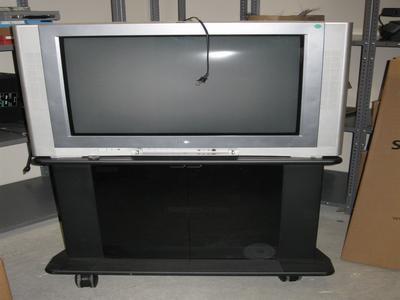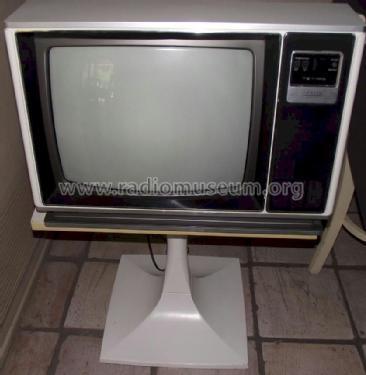The first image is the image on the left, the second image is the image on the right. Assess this claim about the two images: "One of the televsions is on.". Correct or not? Answer yes or no. No. 